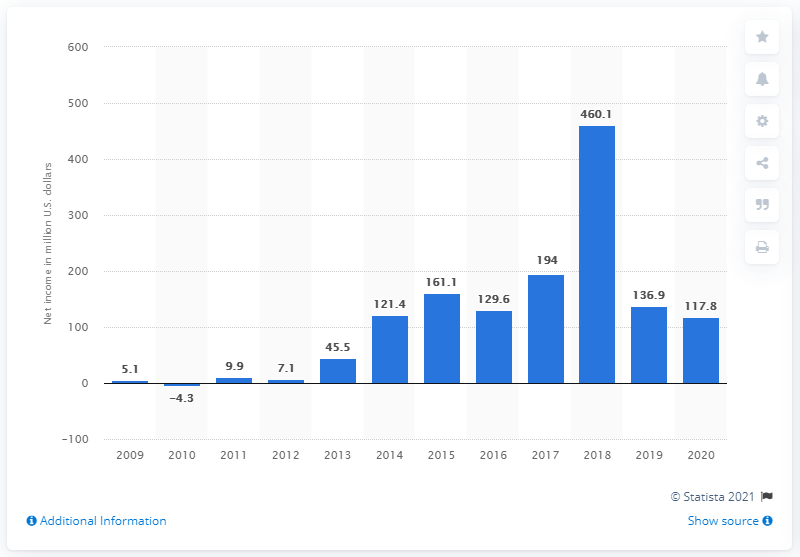Mention a couple of crucial points in this snapshot. In 2020, the net income of The Wendy's Company worldwide was 117.8 million dollars. The previous year's net income was 136.9 million dollars. In 2018, The Wendy's Company reported a net income of 460.1 million dollars. 